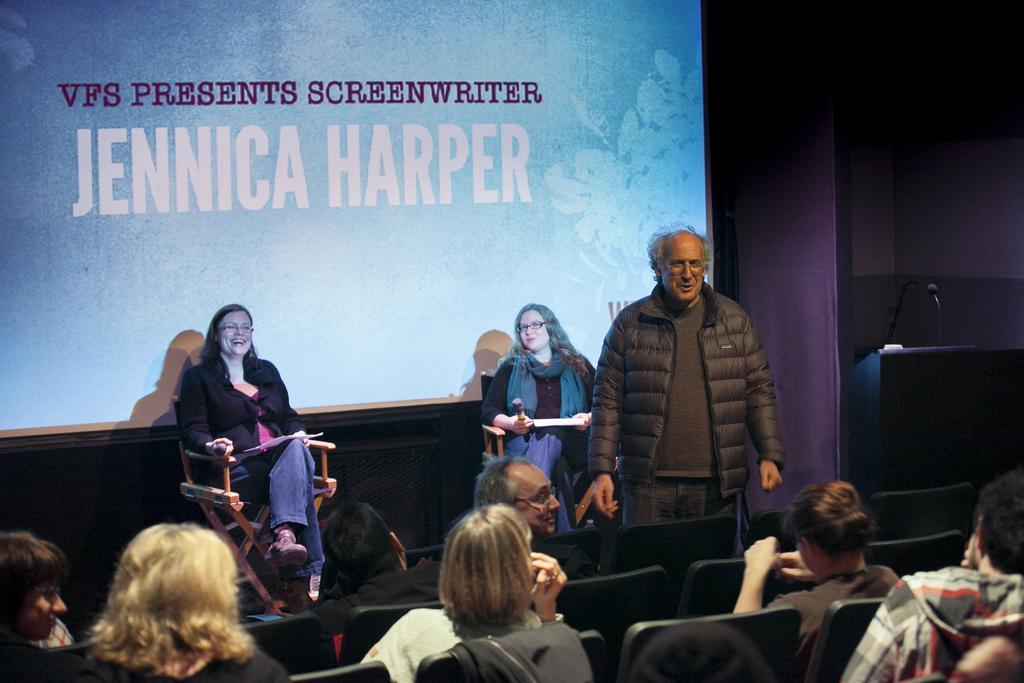What are the people in the image doing? There are people sitting in the image, and a man is standing on the right side. Can you describe the man standing on the right side of the image? The man is standing on the right side of the image. What is visible in the background of the image? There is a screen in the background of the image. What are the ladies sitting in the center holding? The ladies sitting in the center are holding mics and papers. What type of shoe is the man wearing in the image? There is no information about the man's shoes in the image. How many copies of the paper are the ladies holding in the image? The ladies are holding papers, but there is no information about the number of copies in the image. 